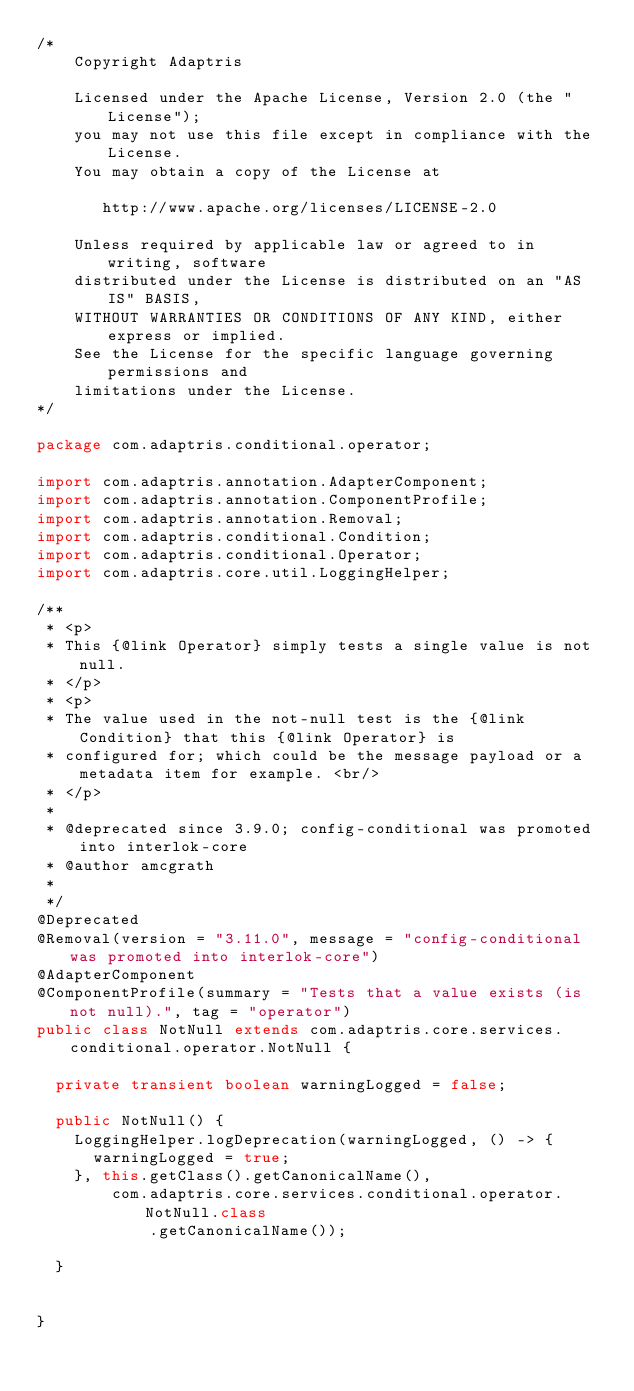<code> <loc_0><loc_0><loc_500><loc_500><_Java_>/*
    Copyright Adaptris

    Licensed under the Apache License, Version 2.0 (the "License");
    you may not use this file except in compliance with the License.
    You may obtain a copy of the License at

       http://www.apache.org/licenses/LICENSE-2.0

    Unless required by applicable law or agreed to in writing, software
    distributed under the License is distributed on an "AS IS" BASIS,
    WITHOUT WARRANTIES OR CONDITIONS OF ANY KIND, either express or implied.
    See the License for the specific language governing permissions and
    limitations under the License.
*/

package com.adaptris.conditional.operator;

import com.adaptris.annotation.AdapterComponent;
import com.adaptris.annotation.ComponentProfile;
import com.adaptris.annotation.Removal;
import com.adaptris.conditional.Condition;
import com.adaptris.conditional.Operator;
import com.adaptris.core.util.LoggingHelper;

/**
 * <p>
 * This {@link Operator} simply tests a single value is not null.
 * </p>
 * <p>
 * The value used in the not-null test is the {@link Condition} that this {@link Operator} is
 * configured for; which could be the message payload or a metadata item for example. <br/>
 * </p>
 * 
 * @deprecated since 3.9.0; config-conditional was promoted into interlok-core
 * @author amcgrath
 *
 */
@Deprecated
@Removal(version = "3.11.0", message = "config-conditional was promoted into interlok-core")
@AdapterComponent
@ComponentProfile(summary = "Tests that a value exists (is not null).", tag = "operator")
public class NotNull extends com.adaptris.core.services.conditional.operator.NotNull {

  private transient boolean warningLogged = false;

  public NotNull() {
    LoggingHelper.logDeprecation(warningLogged, () -> {
      warningLogged = true;
    }, this.getClass().getCanonicalName(),
        com.adaptris.core.services.conditional.operator.NotNull.class
            .getCanonicalName());

  }


}
</code> 